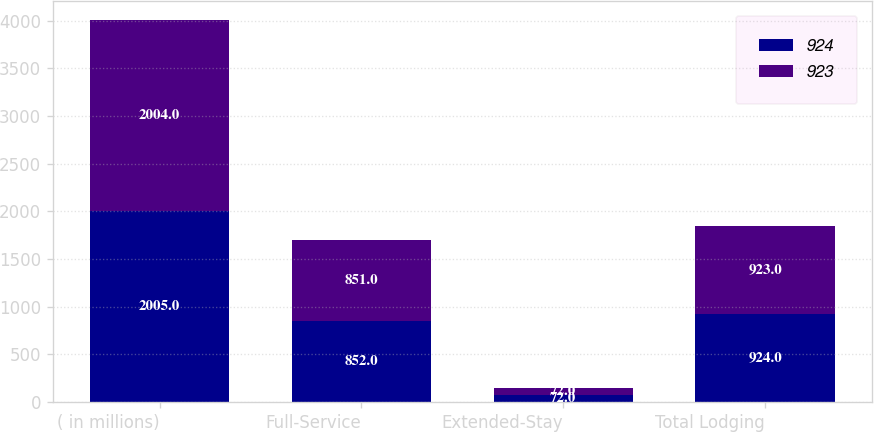Convert chart. <chart><loc_0><loc_0><loc_500><loc_500><stacked_bar_chart><ecel><fcel>( in millions)<fcel>Full-Service<fcel>Extended-Stay<fcel>Total Lodging<nl><fcel>924<fcel>2005<fcel>852<fcel>72<fcel>924<nl><fcel>923<fcel>2004<fcel>851<fcel>72<fcel>923<nl></chart> 